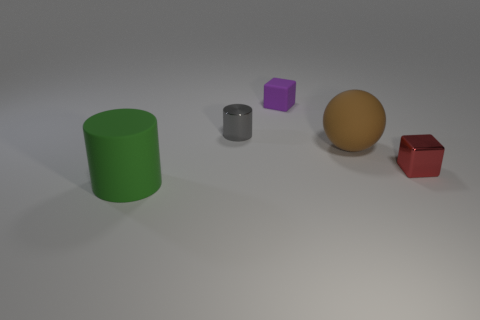What is the material of the tiny red thing?
Offer a terse response. Metal. Is the cube that is in front of the small gray cylinder made of the same material as the brown ball?
Give a very brief answer. No. There is a rubber thing to the left of the metallic cylinder; what is its shape?
Keep it short and to the point. Cylinder. There is a red object that is the same size as the gray shiny thing; what is it made of?
Offer a very short reply. Metal. What number of objects are cylinders left of the gray cylinder or small blocks to the left of the tiny red block?
Your answer should be compact. 2. What is the size of the block that is made of the same material as the tiny gray thing?
Your answer should be very brief. Small. How many metallic objects are either spheres or tiny cyan balls?
Your response must be concise. 0. What size is the green cylinder?
Give a very brief answer. Large. Is the red object the same size as the shiny cylinder?
Provide a succinct answer. Yes. What material is the block that is right of the small purple rubber cube?
Your response must be concise. Metal. 